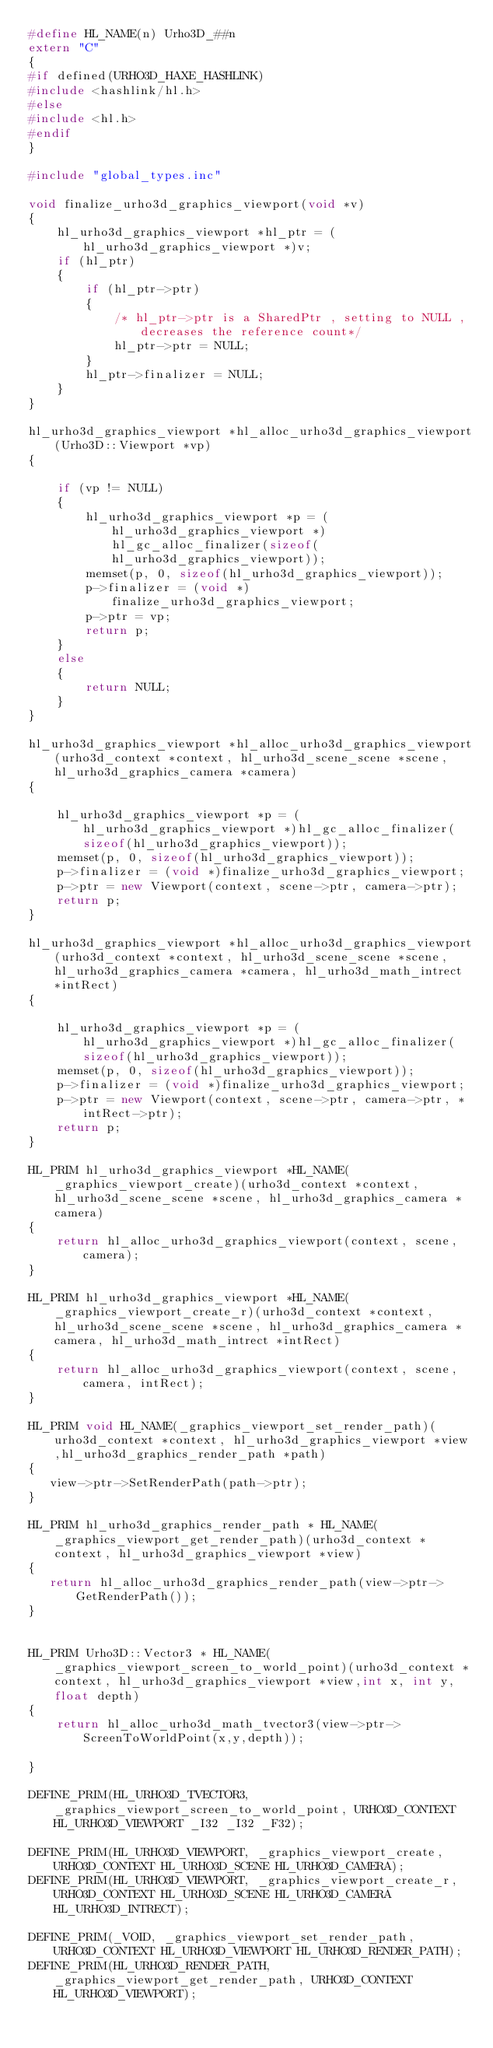Convert code to text. <code><loc_0><loc_0><loc_500><loc_500><_C++_>#define HL_NAME(n) Urho3D_##n
extern "C"
{
#if defined(URHO3D_HAXE_HASHLINK)
#include <hashlink/hl.h>
#else
#include <hl.h>
#endif
}

#include "global_types.inc"

void finalize_urho3d_graphics_viewport(void *v)
{
    hl_urho3d_graphics_viewport *hl_ptr = (hl_urho3d_graphics_viewport *)v;
    if (hl_ptr)
    {
        if (hl_ptr->ptr)
        {
            /* hl_ptr->ptr is a SharedPtr , setting to NULL , decreases the reference count*/
            hl_ptr->ptr = NULL;
        }
        hl_ptr->finalizer = NULL;
    }
}

hl_urho3d_graphics_viewport *hl_alloc_urho3d_graphics_viewport(Urho3D::Viewport *vp)
{

    if (vp != NULL)
    {
        hl_urho3d_graphics_viewport *p = (hl_urho3d_graphics_viewport *)hl_gc_alloc_finalizer(sizeof(hl_urho3d_graphics_viewport));
        memset(p, 0, sizeof(hl_urho3d_graphics_viewport));
        p->finalizer = (void *)finalize_urho3d_graphics_viewport;
        p->ptr = vp;
        return p;
    }
    else
    {
        return NULL;
    }
}

hl_urho3d_graphics_viewport *hl_alloc_urho3d_graphics_viewport(urho3d_context *context, hl_urho3d_scene_scene *scene, hl_urho3d_graphics_camera *camera)
{

    hl_urho3d_graphics_viewport *p = (hl_urho3d_graphics_viewport *)hl_gc_alloc_finalizer(sizeof(hl_urho3d_graphics_viewport));
    memset(p, 0, sizeof(hl_urho3d_graphics_viewport));
    p->finalizer = (void *)finalize_urho3d_graphics_viewport;
    p->ptr = new Viewport(context, scene->ptr, camera->ptr);
    return p;
}

hl_urho3d_graphics_viewport *hl_alloc_urho3d_graphics_viewport(urho3d_context *context, hl_urho3d_scene_scene *scene, hl_urho3d_graphics_camera *camera, hl_urho3d_math_intrect *intRect)
{

    hl_urho3d_graphics_viewport *p = (hl_urho3d_graphics_viewport *)hl_gc_alloc_finalizer(sizeof(hl_urho3d_graphics_viewport));
    memset(p, 0, sizeof(hl_urho3d_graphics_viewport));
    p->finalizer = (void *)finalize_urho3d_graphics_viewport;
    p->ptr = new Viewport(context, scene->ptr, camera->ptr, *intRect->ptr);
    return p;
}

HL_PRIM hl_urho3d_graphics_viewport *HL_NAME(_graphics_viewport_create)(urho3d_context *context, hl_urho3d_scene_scene *scene, hl_urho3d_graphics_camera *camera)
{
    return hl_alloc_urho3d_graphics_viewport(context, scene, camera);
}

HL_PRIM hl_urho3d_graphics_viewport *HL_NAME(_graphics_viewport_create_r)(urho3d_context *context, hl_urho3d_scene_scene *scene, hl_urho3d_graphics_camera *camera, hl_urho3d_math_intrect *intRect)
{
    return hl_alloc_urho3d_graphics_viewport(context, scene, camera, intRect);
}

HL_PRIM void HL_NAME(_graphics_viewport_set_render_path)(urho3d_context *context, hl_urho3d_graphics_viewport *view,hl_urho3d_graphics_render_path *path)
{
   view->ptr->SetRenderPath(path->ptr);
}

HL_PRIM hl_urho3d_graphics_render_path * HL_NAME(_graphics_viewport_get_render_path)(urho3d_context *context, hl_urho3d_graphics_viewport *view)
{
   return hl_alloc_urho3d_graphics_render_path(view->ptr->GetRenderPath());
}


HL_PRIM Urho3D::Vector3 * HL_NAME(_graphics_viewport_screen_to_world_point)(urho3d_context *context, hl_urho3d_graphics_viewport *view,int x, int y, float depth)
{
    return hl_alloc_urho3d_math_tvector3(view->ptr->ScreenToWorldPoint(x,y,depth));

}

DEFINE_PRIM(HL_URHO3D_TVECTOR3, _graphics_viewport_screen_to_world_point, URHO3D_CONTEXT HL_URHO3D_VIEWPORT _I32 _I32 _F32);

DEFINE_PRIM(HL_URHO3D_VIEWPORT, _graphics_viewport_create, URHO3D_CONTEXT HL_URHO3D_SCENE HL_URHO3D_CAMERA);
DEFINE_PRIM(HL_URHO3D_VIEWPORT, _graphics_viewport_create_r, URHO3D_CONTEXT HL_URHO3D_SCENE HL_URHO3D_CAMERA HL_URHO3D_INTRECT);

DEFINE_PRIM(_VOID, _graphics_viewport_set_render_path, URHO3D_CONTEXT HL_URHO3D_VIEWPORT HL_URHO3D_RENDER_PATH);
DEFINE_PRIM(HL_URHO3D_RENDER_PATH, _graphics_viewport_get_render_path, URHO3D_CONTEXT HL_URHO3D_VIEWPORT);</code> 